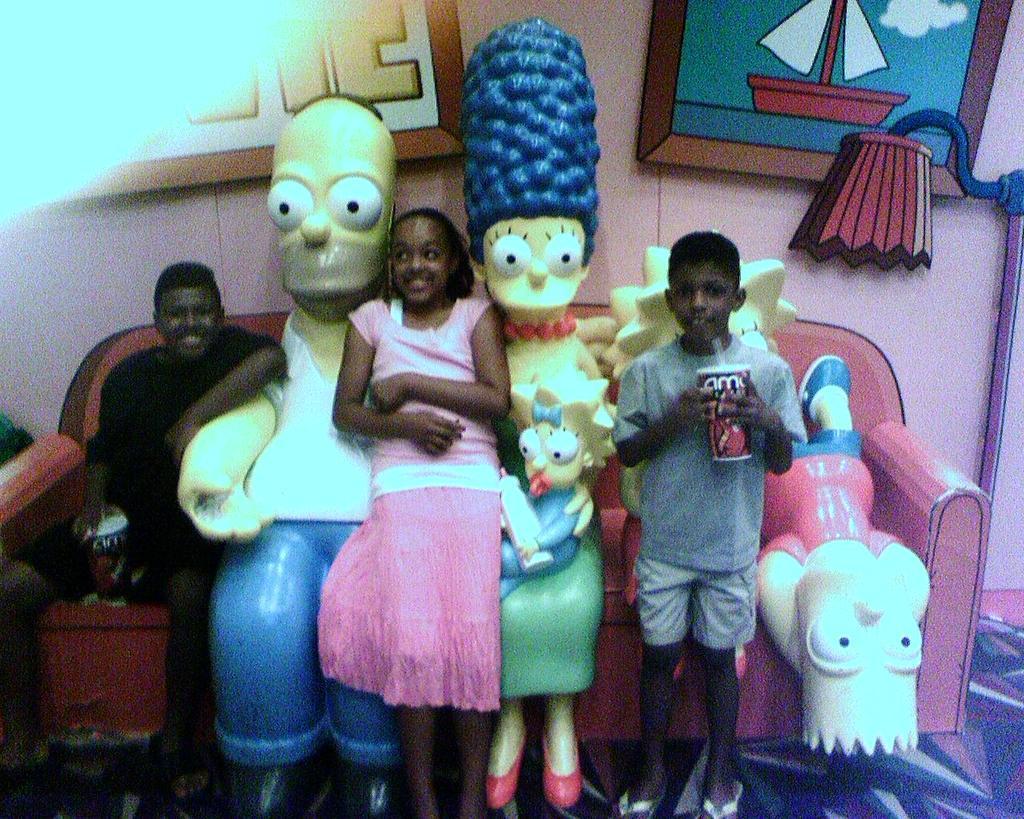Please provide a concise description of this image. In this image I can see three children. I can see two of them are holding cups in their hands and few toys in between them. I can see a couch which is pink in color behind them. In the background I can see the wall and few photo frames attached to the wall. 